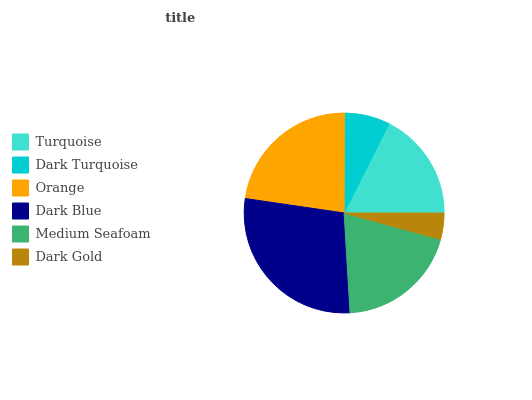Is Dark Gold the minimum?
Answer yes or no. Yes. Is Dark Blue the maximum?
Answer yes or no. Yes. Is Dark Turquoise the minimum?
Answer yes or no. No. Is Dark Turquoise the maximum?
Answer yes or no. No. Is Turquoise greater than Dark Turquoise?
Answer yes or no. Yes. Is Dark Turquoise less than Turquoise?
Answer yes or no. Yes. Is Dark Turquoise greater than Turquoise?
Answer yes or no. No. Is Turquoise less than Dark Turquoise?
Answer yes or no. No. Is Medium Seafoam the high median?
Answer yes or no. Yes. Is Turquoise the low median?
Answer yes or no. Yes. Is Dark Turquoise the high median?
Answer yes or no. No. Is Orange the low median?
Answer yes or no. No. 